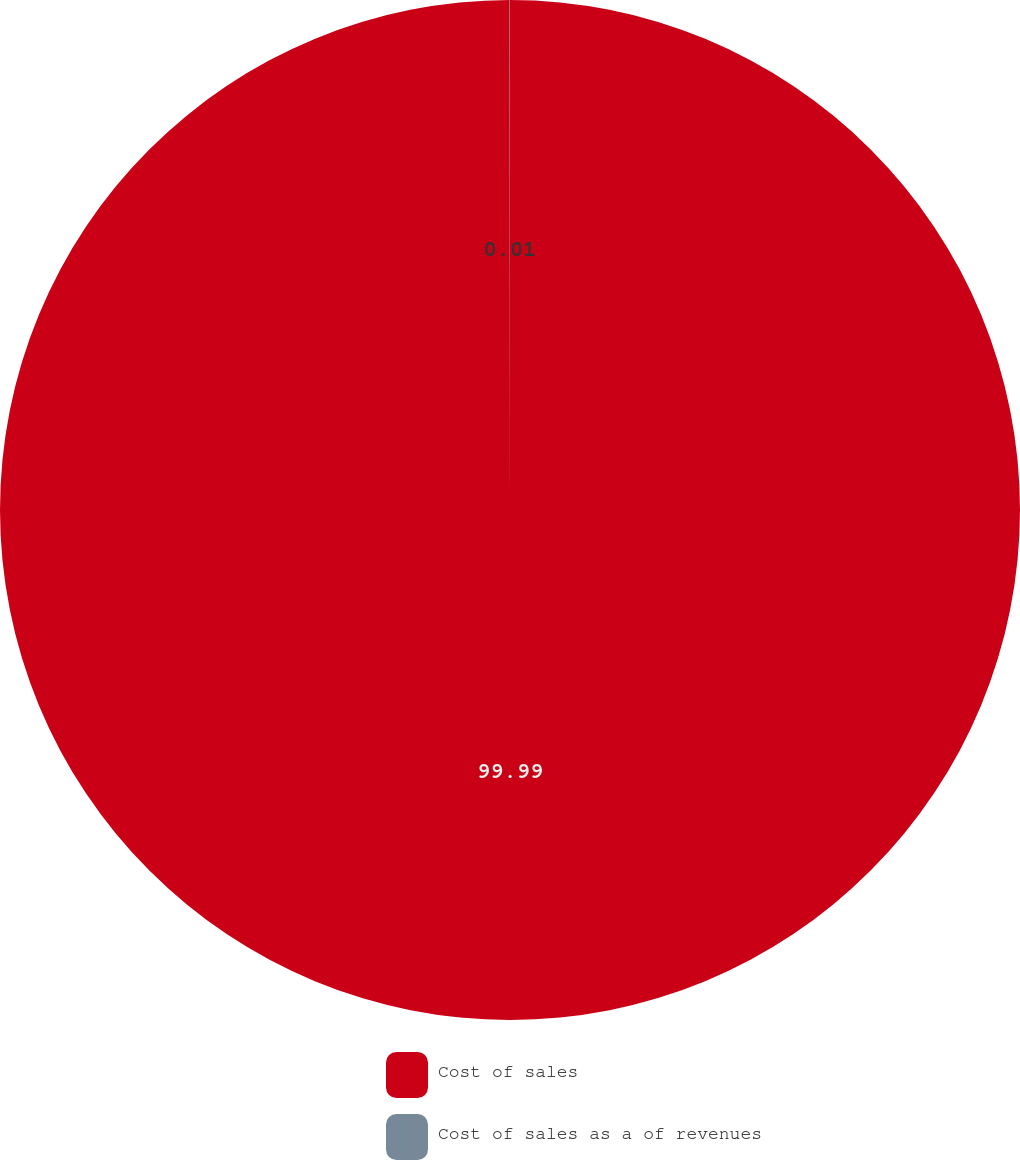Convert chart to OTSL. <chart><loc_0><loc_0><loc_500><loc_500><pie_chart><fcel>Cost of sales<fcel>Cost of sales as a of revenues<nl><fcel>99.99%<fcel>0.01%<nl></chart> 